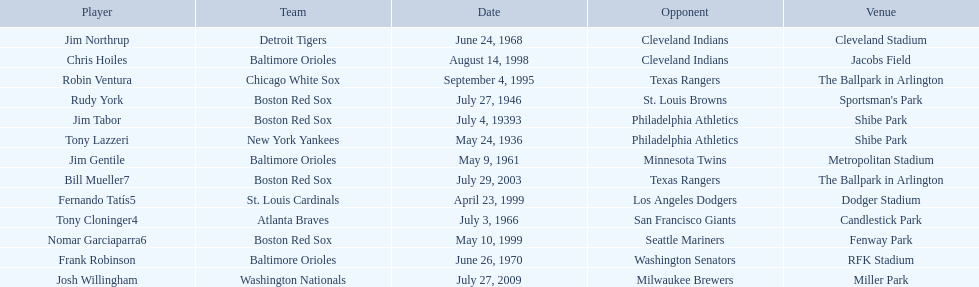Who are all the opponents? Philadelphia Athletics, Philadelphia Athletics, St. Louis Browns, Minnesota Twins, San Francisco Giants, Cleveland Indians, Washington Senators, Texas Rangers, Cleveland Indians, Los Angeles Dodgers, Seattle Mariners, Texas Rangers, Milwaukee Brewers. What teams played on july 27, 1946? Boston Red Sox, July 27, 1946, St. Louis Browns. Who was the opponent in this game? St. Louis Browns. 